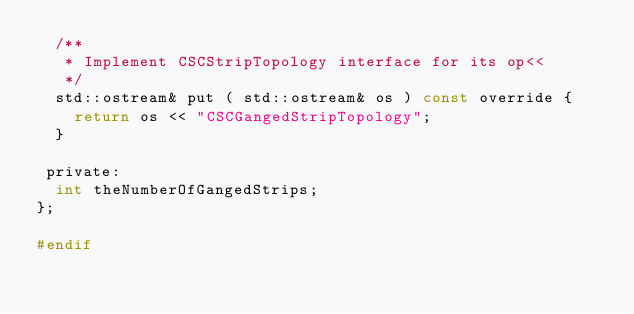<code> <loc_0><loc_0><loc_500><loc_500><_C_>  /**
   * Implement CSCStripTopology interface for its op<<
   */
  std::ostream& put ( std::ostream& os ) const override {
    return os << "CSCGangedStripTopology";
  }

 private:
  int theNumberOfGangedStrips;
};

#endif


</code> 